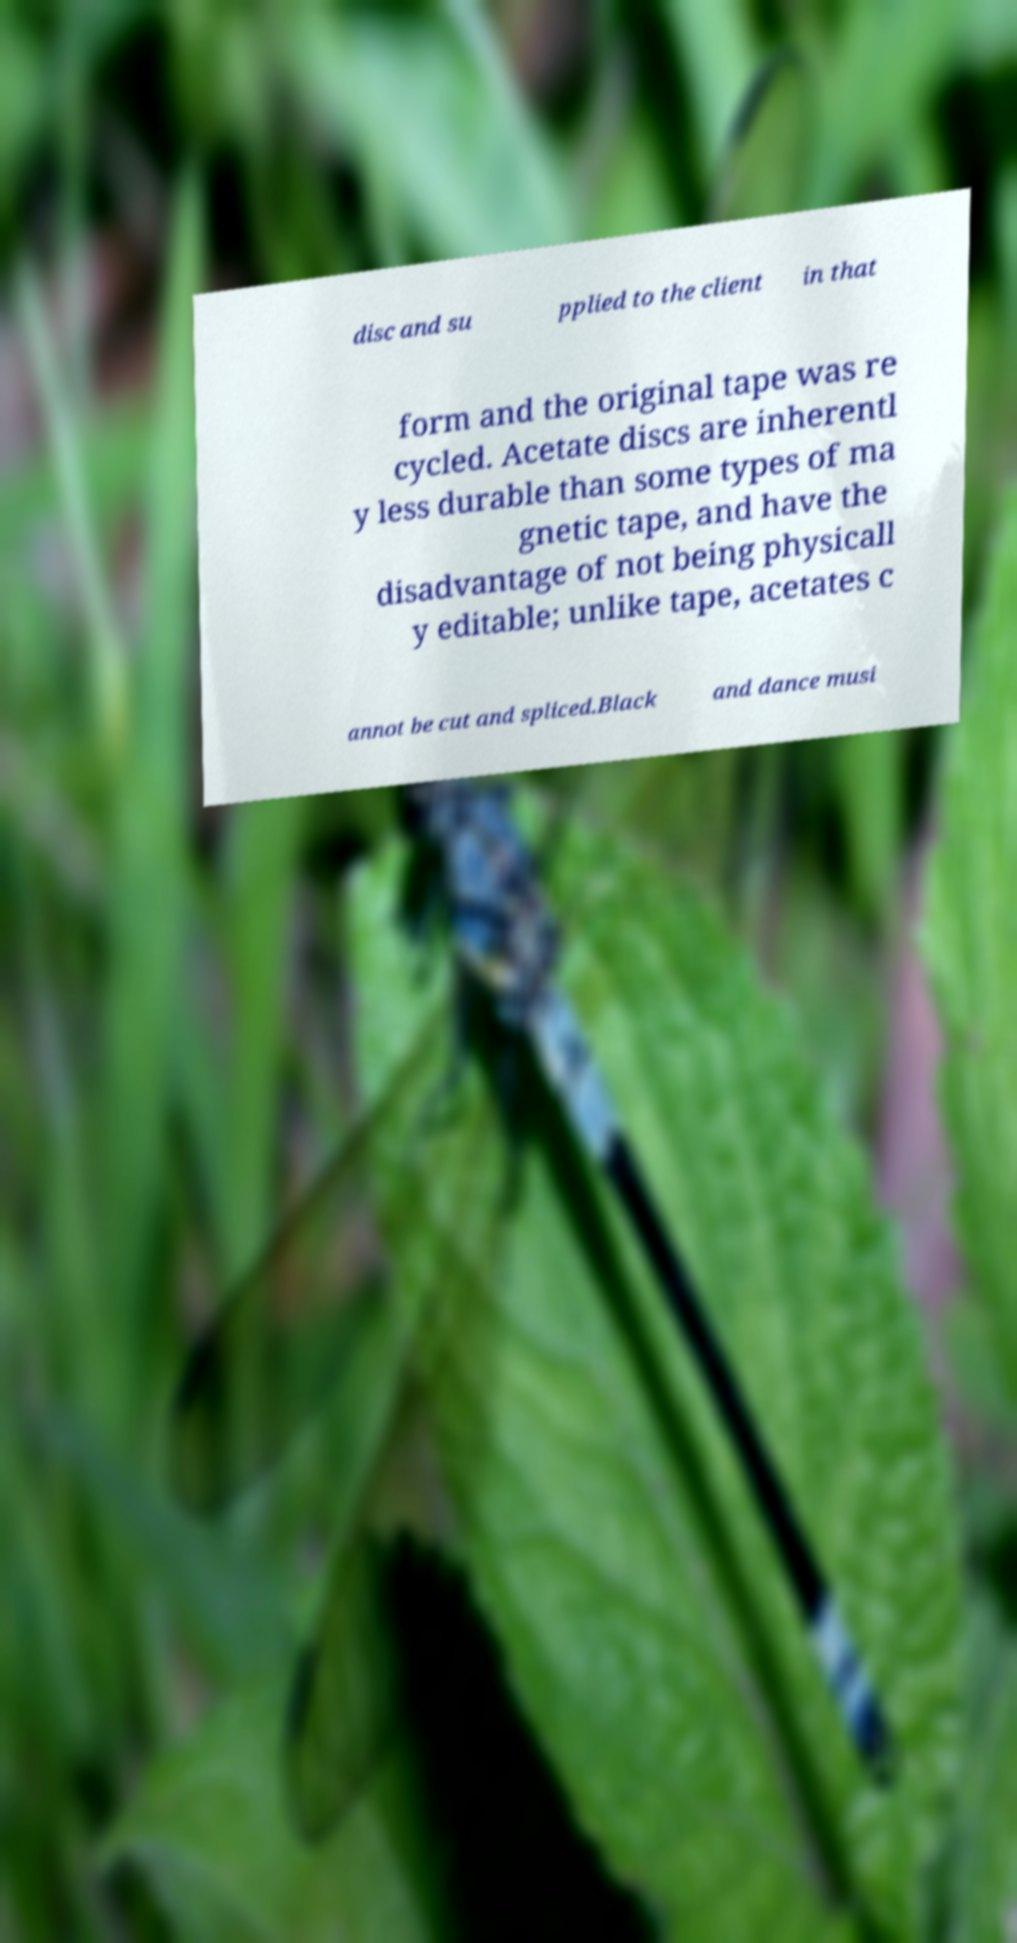What messages or text are displayed in this image? I need them in a readable, typed format. disc and su pplied to the client in that form and the original tape was re cycled. Acetate discs are inherentl y less durable than some types of ma gnetic tape, and have the disadvantage of not being physicall y editable; unlike tape, acetates c annot be cut and spliced.Black and dance musi 